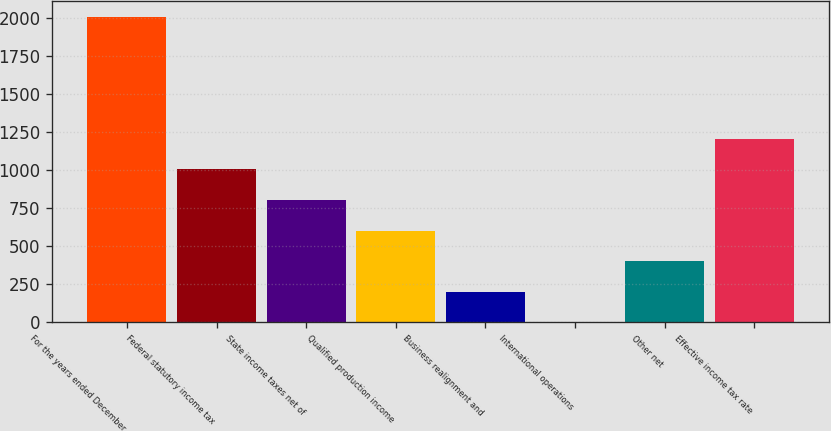Convert chart. <chart><loc_0><loc_0><loc_500><loc_500><bar_chart><fcel>For the years ended December<fcel>Federal statutory income tax<fcel>State income taxes net of<fcel>Qualified production income<fcel>Business realignment and<fcel>International operations<fcel>Other net<fcel>Effective income tax rate<nl><fcel>2009<fcel>1004.55<fcel>803.66<fcel>602.77<fcel>200.99<fcel>0.1<fcel>401.88<fcel>1205.44<nl></chart> 